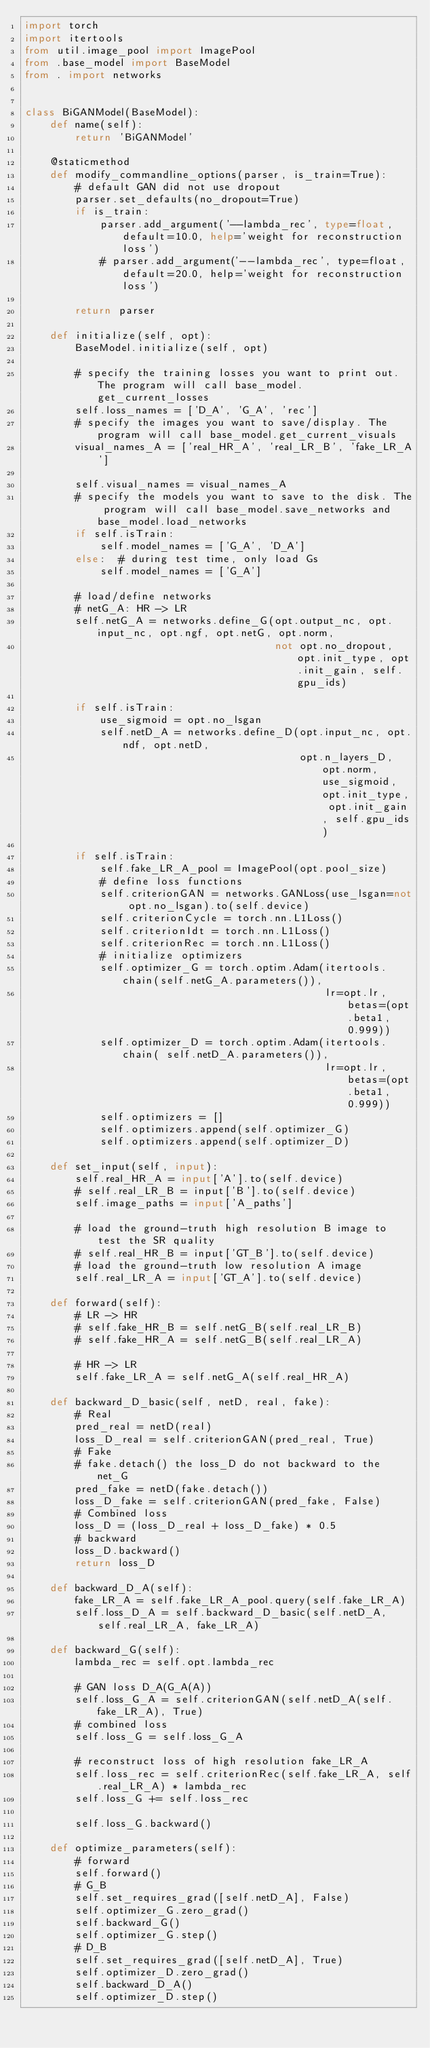Convert code to text. <code><loc_0><loc_0><loc_500><loc_500><_Python_>import torch
import itertools
from util.image_pool import ImagePool
from .base_model import BaseModel
from . import networks


class BiGANModel(BaseModel):
    def name(self):
        return 'BiGANModel'

    @staticmethod
    def modify_commandline_options(parser, is_train=True):
        # default GAN did not use dropout
        parser.set_defaults(no_dropout=True)
        if is_train:
            parser.add_argument('--lambda_rec', type=float, default=10.0, help='weight for reconstruction loss')
            # parser.add_argument('--lambda_rec', type=float, default=20.0, help='weight for reconstruction loss')

        return parser

    def initialize(self, opt):
        BaseModel.initialize(self, opt)

        # specify the training losses you want to print out. The program will call base_model.get_current_losses
        self.loss_names = ['D_A', 'G_A', 'rec']
        # specify the images you want to save/display. The program will call base_model.get_current_visuals
        visual_names_A = ['real_HR_A', 'real_LR_B', 'fake_LR_A']

        self.visual_names = visual_names_A
        # specify the models you want to save to the disk. The program will call base_model.save_networks and base_model.load_networks
        if self.isTrain:
            self.model_names = ['G_A', 'D_A']
        else:  # during test time, only load Gs
            self.model_names = ['G_A']

        # load/define networks
        # netG_A: HR -> LR
        self.netG_A = networks.define_G(opt.output_nc, opt.input_nc, opt.ngf, opt.netG, opt.norm,
                                        not opt.no_dropout, opt.init_type, opt.init_gain, self.gpu_ids)

        if self.isTrain:
            use_sigmoid = opt.no_lsgan
            self.netD_A = networks.define_D(opt.input_nc, opt.ndf, opt.netD,
                                            opt.n_layers_D, opt.norm, use_sigmoid, opt.init_type, opt.init_gain, self.gpu_ids)

        if self.isTrain:
            self.fake_LR_A_pool = ImagePool(opt.pool_size)
            # define loss functions
            self.criterionGAN = networks.GANLoss(use_lsgan=not opt.no_lsgan).to(self.device)
            self.criterionCycle = torch.nn.L1Loss()
            self.criterionIdt = torch.nn.L1Loss()
            self.criterionRec = torch.nn.L1Loss()
            # initialize optimizers
            self.optimizer_G = torch.optim.Adam(itertools.chain(self.netG_A.parameters()),
                                                lr=opt.lr, betas=(opt.beta1, 0.999))
            self.optimizer_D = torch.optim.Adam(itertools.chain( self.netD_A.parameters()),
                                                lr=opt.lr, betas=(opt.beta1, 0.999))
            self.optimizers = []
            self.optimizers.append(self.optimizer_G)
            self.optimizers.append(self.optimizer_D)

    def set_input(self, input):
        self.real_HR_A = input['A'].to(self.device)
        # self.real_LR_B = input['B'].to(self.device)
        self.image_paths = input['A_paths']

        # load the ground-truth high resolution B image to test the SR quality
        # self.real_HR_B = input['GT_B'].to(self.device)
        # load the ground-truth low resolution A image
        self.real_LR_A = input['GT_A'].to(self.device)

    def forward(self):
        # LR -> HR
        # self.fake_HR_B = self.netG_B(self.real_LR_B)
        # self.fake_HR_A = self.netG_B(self.real_LR_A)

        # HR -> LR
        self.fake_LR_A = self.netG_A(self.real_HR_A)

    def backward_D_basic(self, netD, real, fake):
        # Real
        pred_real = netD(real)
        loss_D_real = self.criterionGAN(pred_real, True)
        # Fake
        # fake.detach() the loss_D do not backward to the net_G
        pred_fake = netD(fake.detach())
        loss_D_fake = self.criterionGAN(pred_fake, False)
        # Combined loss
        loss_D = (loss_D_real + loss_D_fake) * 0.5
        # backward
        loss_D.backward()
        return loss_D

    def backward_D_A(self):
        fake_LR_A = self.fake_LR_A_pool.query(self.fake_LR_A)
        self.loss_D_A = self.backward_D_basic(self.netD_A, self.real_LR_A, fake_LR_A)

    def backward_G(self):
        lambda_rec = self.opt.lambda_rec

        # GAN loss D_A(G_A(A))
        self.loss_G_A = self.criterionGAN(self.netD_A(self.fake_LR_A), True)
        # combined loss
        self.loss_G = self.loss_G_A

        # reconstruct loss of high resolution fake_LR_A
        self.loss_rec = self.criterionRec(self.fake_LR_A, self.real_LR_A) * lambda_rec
        self.loss_G += self.loss_rec

        self.loss_G.backward()

    def optimize_parameters(self):
        # forward
        self.forward()
        # G_B
        self.set_requires_grad([self.netD_A], False)
        self.optimizer_G.zero_grad()
        self.backward_G()
        self.optimizer_G.step()
        # D_B
        self.set_requires_grad([self.netD_A], True)
        self.optimizer_D.zero_grad()
        self.backward_D_A()
        self.optimizer_D.step()
</code> 